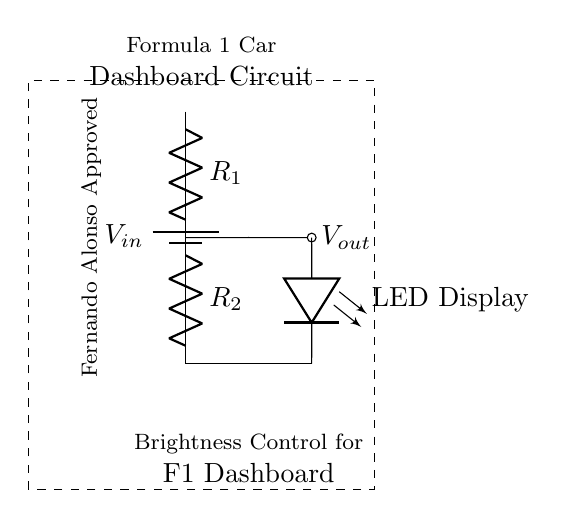What is the purpose of R1 in the circuit? R1 serves as a resistor to create a voltage drop, allowing some of the input voltage to be used across R2 and subsequently across the LED Display.
Answer: voltage drop What is the output voltage labeled in the circuit? The output voltage, labeled as Vout, is taken from the junction between R1 and R2, representing the voltage available for the LED Display after R1 has reduced the input voltage.
Answer: Vout What type of circuit is this? This is a voltage divider circuit, which is specifically designed to take an input voltage and divide it across two resistors to adjust the output voltage, in this case for controlling LED brightness.
Answer: voltage divider How many resistors are present in the circuit? There are two resistors in the circuit, R1 and R2, which work together to create the desired voltage drop for the LED display.
Answer: two What is the primary function of the LED display in this circuit? The primary function of the LED display is to visually indicate the current state of the dashboard or provide feedback to the driver, made brighter or dimmer by adjusting the output voltage from the voltage divider.
Answer: indicate state How does adjusting R1 affect the LED brightness? Adjusting R1 changes the resistance and alters the voltage drop across R1, which in turn changes the output voltage at the LED Display. A higher R1 resistance reduces brightness, while a lower resistance increases it.
Answer: affects brightness 